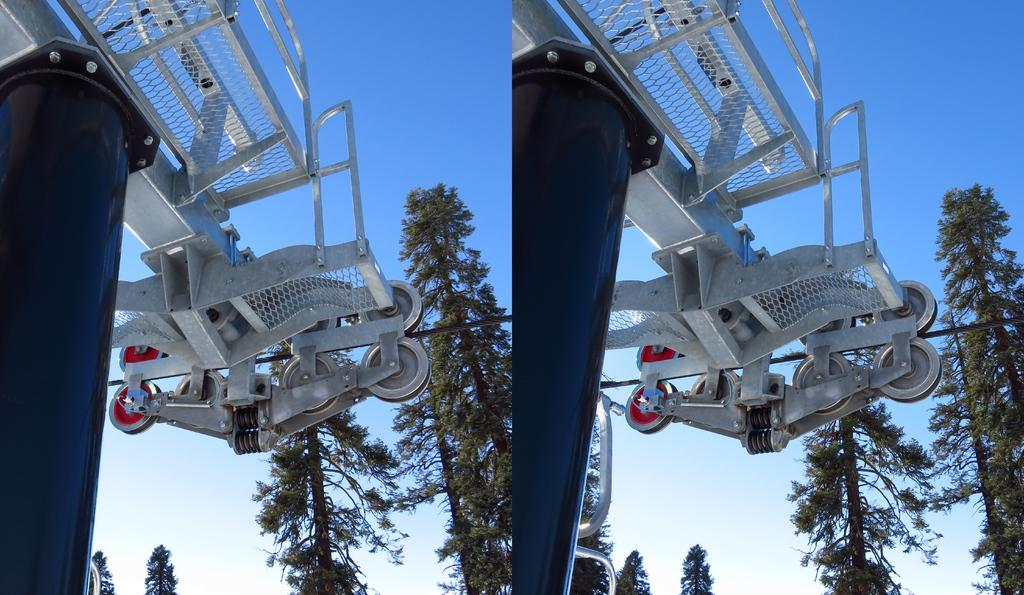What is the main object in the image? There is a machine with cables in the image. What can be seen in the background of the image? There are trees in the background of the image. How many children are playing with scissors in the image? There are no children or scissors present in the image. 